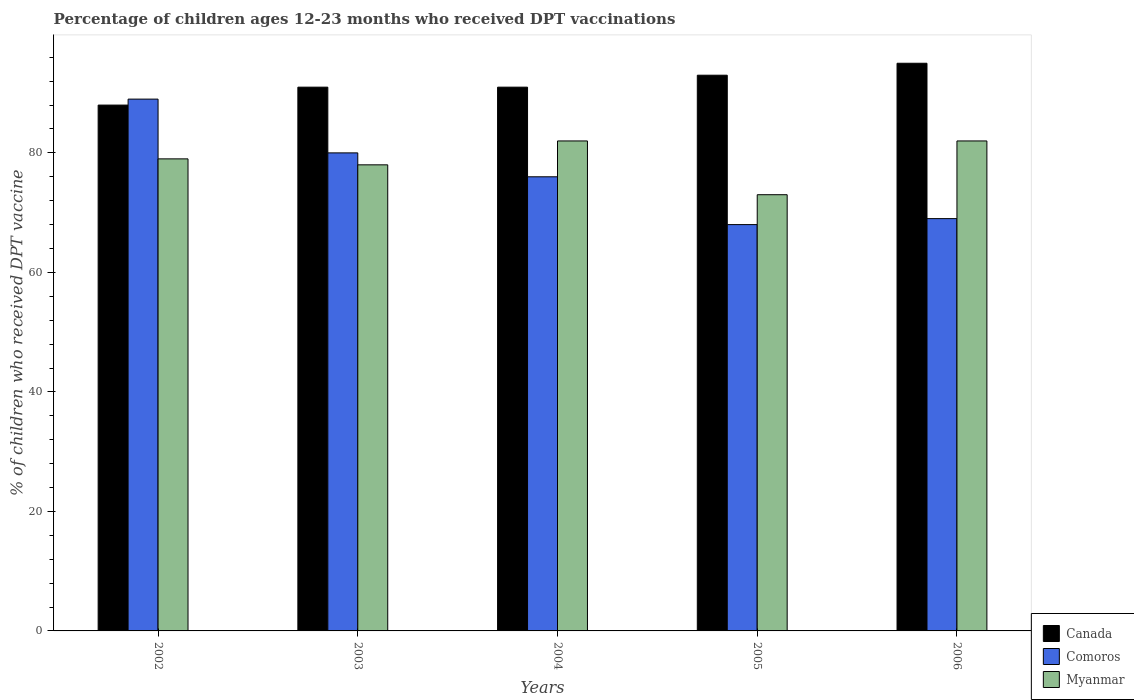How many different coloured bars are there?
Provide a succinct answer. 3. Are the number of bars on each tick of the X-axis equal?
Offer a very short reply. Yes. What is the label of the 5th group of bars from the left?
Provide a short and direct response. 2006. What is the percentage of children who received DPT vaccination in Canada in 2005?
Make the answer very short. 93. In which year was the percentage of children who received DPT vaccination in Myanmar maximum?
Provide a succinct answer. 2004. What is the total percentage of children who received DPT vaccination in Comoros in the graph?
Offer a very short reply. 382. What is the difference between the percentage of children who received DPT vaccination in Myanmar in 2002 and that in 2004?
Provide a succinct answer. -3. What is the difference between the percentage of children who received DPT vaccination in Myanmar in 2003 and the percentage of children who received DPT vaccination in Canada in 2004?
Make the answer very short. -13. What is the average percentage of children who received DPT vaccination in Comoros per year?
Offer a very short reply. 76.4. In how many years, is the percentage of children who received DPT vaccination in Comoros greater than 56 %?
Ensure brevity in your answer.  5. What is the ratio of the percentage of children who received DPT vaccination in Canada in 2004 to that in 2005?
Keep it short and to the point. 0.98. Is the difference between the percentage of children who received DPT vaccination in Myanmar in 2004 and 2006 greater than the difference between the percentage of children who received DPT vaccination in Comoros in 2004 and 2006?
Ensure brevity in your answer.  No. What is the difference between the highest and the lowest percentage of children who received DPT vaccination in Canada?
Your answer should be very brief. 7. What does the 3rd bar from the left in 2006 represents?
Give a very brief answer. Myanmar. What does the 1st bar from the right in 2003 represents?
Ensure brevity in your answer.  Myanmar. Is it the case that in every year, the sum of the percentage of children who received DPT vaccination in Canada and percentage of children who received DPT vaccination in Comoros is greater than the percentage of children who received DPT vaccination in Myanmar?
Provide a succinct answer. Yes. Are all the bars in the graph horizontal?
Keep it short and to the point. No. What is the difference between two consecutive major ticks on the Y-axis?
Provide a succinct answer. 20. Does the graph contain grids?
Your answer should be compact. No. Where does the legend appear in the graph?
Provide a succinct answer. Bottom right. How are the legend labels stacked?
Provide a succinct answer. Vertical. What is the title of the graph?
Your answer should be very brief. Percentage of children ages 12-23 months who received DPT vaccinations. What is the label or title of the X-axis?
Your answer should be compact. Years. What is the label or title of the Y-axis?
Give a very brief answer. % of children who received DPT vaccine. What is the % of children who received DPT vaccine in Comoros in 2002?
Ensure brevity in your answer.  89. What is the % of children who received DPT vaccine in Myanmar in 2002?
Your response must be concise. 79. What is the % of children who received DPT vaccine in Canada in 2003?
Your answer should be very brief. 91. What is the % of children who received DPT vaccine of Comoros in 2003?
Ensure brevity in your answer.  80. What is the % of children who received DPT vaccine in Canada in 2004?
Ensure brevity in your answer.  91. What is the % of children who received DPT vaccine in Canada in 2005?
Provide a succinct answer. 93. What is the % of children who received DPT vaccine of Myanmar in 2005?
Provide a succinct answer. 73. What is the % of children who received DPT vaccine of Comoros in 2006?
Give a very brief answer. 69. What is the % of children who received DPT vaccine of Myanmar in 2006?
Keep it short and to the point. 82. Across all years, what is the maximum % of children who received DPT vaccine in Canada?
Your response must be concise. 95. Across all years, what is the maximum % of children who received DPT vaccine of Comoros?
Ensure brevity in your answer.  89. Across all years, what is the minimum % of children who received DPT vaccine in Myanmar?
Your response must be concise. 73. What is the total % of children who received DPT vaccine of Canada in the graph?
Provide a short and direct response. 458. What is the total % of children who received DPT vaccine of Comoros in the graph?
Provide a succinct answer. 382. What is the total % of children who received DPT vaccine in Myanmar in the graph?
Your answer should be very brief. 394. What is the difference between the % of children who received DPT vaccine of Canada in 2002 and that in 2003?
Your response must be concise. -3. What is the difference between the % of children who received DPT vaccine in Comoros in 2002 and that in 2005?
Your answer should be compact. 21. What is the difference between the % of children who received DPT vaccine of Canada in 2002 and that in 2006?
Ensure brevity in your answer.  -7. What is the difference between the % of children who received DPT vaccine of Comoros in 2002 and that in 2006?
Ensure brevity in your answer.  20. What is the difference between the % of children who received DPT vaccine in Canada in 2003 and that in 2004?
Your answer should be very brief. 0. What is the difference between the % of children who received DPT vaccine of Comoros in 2003 and that in 2004?
Provide a short and direct response. 4. What is the difference between the % of children who received DPT vaccine of Myanmar in 2003 and that in 2004?
Offer a terse response. -4. What is the difference between the % of children who received DPT vaccine in Myanmar in 2003 and that in 2006?
Your response must be concise. -4. What is the difference between the % of children who received DPT vaccine of Canada in 2004 and that in 2005?
Make the answer very short. -2. What is the difference between the % of children who received DPT vaccine in Myanmar in 2004 and that in 2005?
Ensure brevity in your answer.  9. What is the difference between the % of children who received DPT vaccine in Canada in 2004 and that in 2006?
Your answer should be very brief. -4. What is the difference between the % of children who received DPT vaccine in Comoros in 2004 and that in 2006?
Offer a terse response. 7. What is the difference between the % of children who received DPT vaccine in Myanmar in 2004 and that in 2006?
Ensure brevity in your answer.  0. What is the difference between the % of children who received DPT vaccine of Canada in 2005 and that in 2006?
Provide a short and direct response. -2. What is the difference between the % of children who received DPT vaccine of Myanmar in 2005 and that in 2006?
Offer a very short reply. -9. What is the difference between the % of children who received DPT vaccine in Canada in 2002 and the % of children who received DPT vaccine in Comoros in 2003?
Provide a succinct answer. 8. What is the difference between the % of children who received DPT vaccine of Canada in 2002 and the % of children who received DPT vaccine of Myanmar in 2003?
Your response must be concise. 10. What is the difference between the % of children who received DPT vaccine in Comoros in 2002 and the % of children who received DPT vaccine in Myanmar in 2003?
Offer a terse response. 11. What is the difference between the % of children who received DPT vaccine in Canada in 2002 and the % of children who received DPT vaccine in Comoros in 2004?
Your answer should be compact. 12. What is the difference between the % of children who received DPT vaccine of Canada in 2002 and the % of children who received DPT vaccine of Myanmar in 2004?
Offer a terse response. 6. What is the difference between the % of children who received DPT vaccine in Canada in 2002 and the % of children who received DPT vaccine in Comoros in 2005?
Your response must be concise. 20. What is the difference between the % of children who received DPT vaccine of Canada in 2003 and the % of children who received DPT vaccine of Comoros in 2004?
Your answer should be very brief. 15. What is the difference between the % of children who received DPT vaccine of Comoros in 2003 and the % of children who received DPT vaccine of Myanmar in 2004?
Ensure brevity in your answer.  -2. What is the difference between the % of children who received DPT vaccine in Canada in 2003 and the % of children who received DPT vaccine in Comoros in 2005?
Make the answer very short. 23. What is the difference between the % of children who received DPT vaccine in Canada in 2003 and the % of children who received DPT vaccine in Comoros in 2006?
Give a very brief answer. 22. What is the difference between the % of children who received DPT vaccine of Comoros in 2004 and the % of children who received DPT vaccine of Myanmar in 2005?
Your answer should be compact. 3. What is the difference between the % of children who received DPT vaccine in Canada in 2004 and the % of children who received DPT vaccine in Myanmar in 2006?
Your answer should be compact. 9. What is the difference between the % of children who received DPT vaccine of Comoros in 2004 and the % of children who received DPT vaccine of Myanmar in 2006?
Your answer should be very brief. -6. What is the difference between the % of children who received DPT vaccine of Canada in 2005 and the % of children who received DPT vaccine of Myanmar in 2006?
Provide a short and direct response. 11. What is the average % of children who received DPT vaccine of Canada per year?
Your answer should be compact. 91.6. What is the average % of children who received DPT vaccine in Comoros per year?
Offer a terse response. 76.4. What is the average % of children who received DPT vaccine of Myanmar per year?
Ensure brevity in your answer.  78.8. In the year 2004, what is the difference between the % of children who received DPT vaccine of Canada and % of children who received DPT vaccine of Comoros?
Your answer should be very brief. 15. In the year 2004, what is the difference between the % of children who received DPT vaccine of Comoros and % of children who received DPT vaccine of Myanmar?
Give a very brief answer. -6. In the year 2005, what is the difference between the % of children who received DPT vaccine in Canada and % of children who received DPT vaccine in Myanmar?
Ensure brevity in your answer.  20. In the year 2006, what is the difference between the % of children who received DPT vaccine of Canada and % of children who received DPT vaccine of Comoros?
Make the answer very short. 26. What is the ratio of the % of children who received DPT vaccine in Comoros in 2002 to that in 2003?
Ensure brevity in your answer.  1.11. What is the ratio of the % of children who received DPT vaccine in Myanmar in 2002 to that in 2003?
Your answer should be very brief. 1.01. What is the ratio of the % of children who received DPT vaccine of Comoros in 2002 to that in 2004?
Your answer should be very brief. 1.17. What is the ratio of the % of children who received DPT vaccine in Myanmar in 2002 to that in 2004?
Make the answer very short. 0.96. What is the ratio of the % of children who received DPT vaccine of Canada in 2002 to that in 2005?
Offer a terse response. 0.95. What is the ratio of the % of children who received DPT vaccine of Comoros in 2002 to that in 2005?
Your answer should be very brief. 1.31. What is the ratio of the % of children who received DPT vaccine of Myanmar in 2002 to that in 2005?
Give a very brief answer. 1.08. What is the ratio of the % of children who received DPT vaccine of Canada in 2002 to that in 2006?
Keep it short and to the point. 0.93. What is the ratio of the % of children who received DPT vaccine in Comoros in 2002 to that in 2006?
Offer a terse response. 1.29. What is the ratio of the % of children who received DPT vaccine of Myanmar in 2002 to that in 2006?
Keep it short and to the point. 0.96. What is the ratio of the % of children who received DPT vaccine of Comoros in 2003 to that in 2004?
Keep it short and to the point. 1.05. What is the ratio of the % of children who received DPT vaccine in Myanmar in 2003 to that in 2004?
Your answer should be compact. 0.95. What is the ratio of the % of children who received DPT vaccine in Canada in 2003 to that in 2005?
Keep it short and to the point. 0.98. What is the ratio of the % of children who received DPT vaccine of Comoros in 2003 to that in 2005?
Your answer should be very brief. 1.18. What is the ratio of the % of children who received DPT vaccine of Myanmar in 2003 to that in 2005?
Provide a succinct answer. 1.07. What is the ratio of the % of children who received DPT vaccine of Canada in 2003 to that in 2006?
Offer a terse response. 0.96. What is the ratio of the % of children who received DPT vaccine in Comoros in 2003 to that in 2006?
Ensure brevity in your answer.  1.16. What is the ratio of the % of children who received DPT vaccine in Myanmar in 2003 to that in 2006?
Your answer should be compact. 0.95. What is the ratio of the % of children who received DPT vaccine in Canada in 2004 to that in 2005?
Your response must be concise. 0.98. What is the ratio of the % of children who received DPT vaccine of Comoros in 2004 to that in 2005?
Provide a succinct answer. 1.12. What is the ratio of the % of children who received DPT vaccine in Myanmar in 2004 to that in 2005?
Provide a short and direct response. 1.12. What is the ratio of the % of children who received DPT vaccine in Canada in 2004 to that in 2006?
Keep it short and to the point. 0.96. What is the ratio of the % of children who received DPT vaccine in Comoros in 2004 to that in 2006?
Your answer should be compact. 1.1. What is the ratio of the % of children who received DPT vaccine in Canada in 2005 to that in 2006?
Offer a terse response. 0.98. What is the ratio of the % of children who received DPT vaccine of Comoros in 2005 to that in 2006?
Your answer should be very brief. 0.99. What is the ratio of the % of children who received DPT vaccine of Myanmar in 2005 to that in 2006?
Your answer should be compact. 0.89. What is the difference between the highest and the lowest % of children who received DPT vaccine of Canada?
Your response must be concise. 7. 